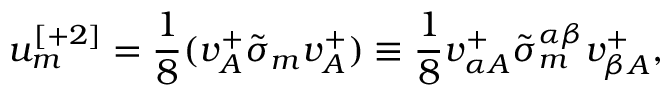Convert formula to latex. <formula><loc_0><loc_0><loc_500><loc_500>u _ { m } ^ { [ + 2 ] } = { \frac { 1 } { 8 } } ( v _ { A } ^ { + } \tilde { \sigma } _ { m } v _ { A } ^ { + } ) \equiv \frac { 1 } { 8 } v _ { \alpha { A } } ^ { + } \tilde { \sigma } _ { m } ^ { \alpha \beta } v _ { \beta { A } } ^ { + } ,</formula> 